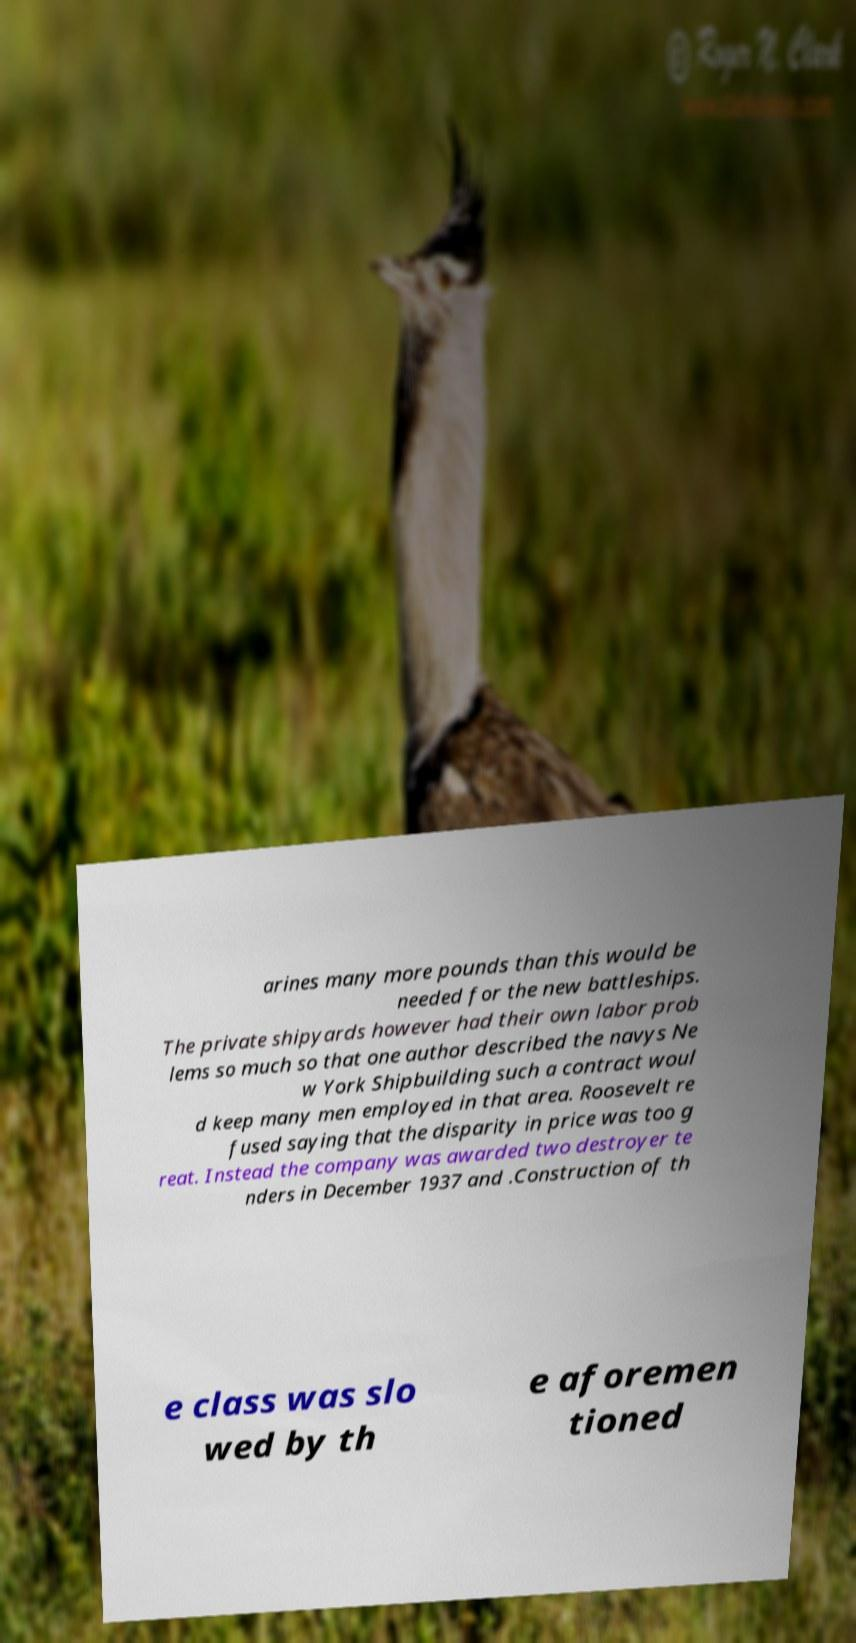Could you extract and type out the text from this image? arines many more pounds than this would be needed for the new battleships. The private shipyards however had their own labor prob lems so much so that one author described the navys Ne w York Shipbuilding such a contract woul d keep many men employed in that area. Roosevelt re fused saying that the disparity in price was too g reat. Instead the company was awarded two destroyer te nders in December 1937 and .Construction of th e class was slo wed by th e aforemen tioned 